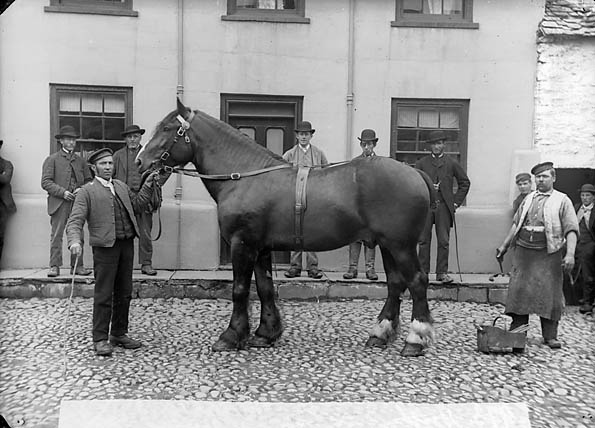Describe the objects in this image and their specific colors. I can see horse in black, gray, darkgray, and lightgray tones, people in black, gray, darkgray, and lightgray tones, people in black, gray, darkgray, and lightgray tones, people in black, gray, darkgray, and lightgray tones, and people in black, gray, darkgray, and lightgray tones in this image. 